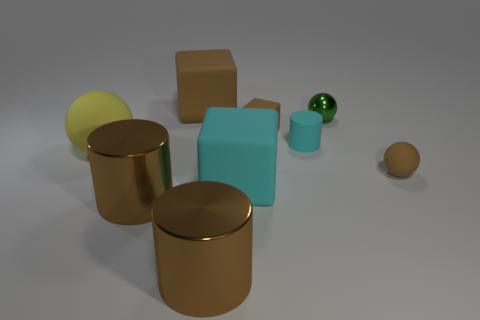Add 1 green metal balls. How many objects exist? 10 Subtract all cubes. How many objects are left? 6 Subtract 2 brown blocks. How many objects are left? 7 Subtract all small rubber things. Subtract all big matte balls. How many objects are left? 5 Add 7 brown metal objects. How many brown metal objects are left? 9 Add 3 metallic objects. How many metallic objects exist? 6 